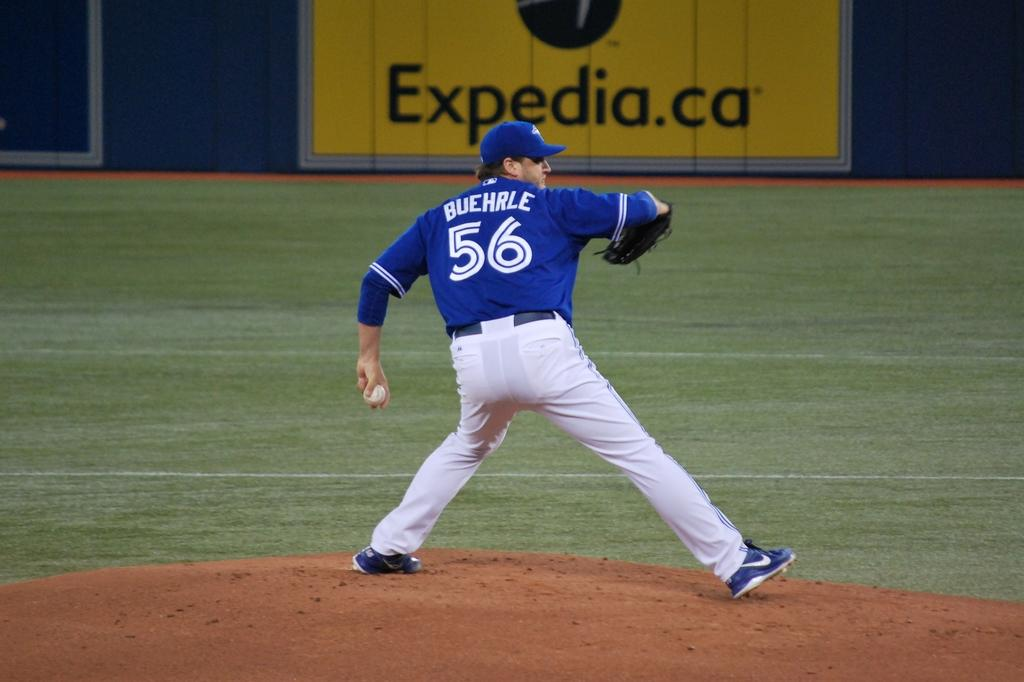<image>
Create a compact narrative representing the image presented. Baseball player pitching the ball in front of a yellow sign that has Expedia.ca in black letters. 